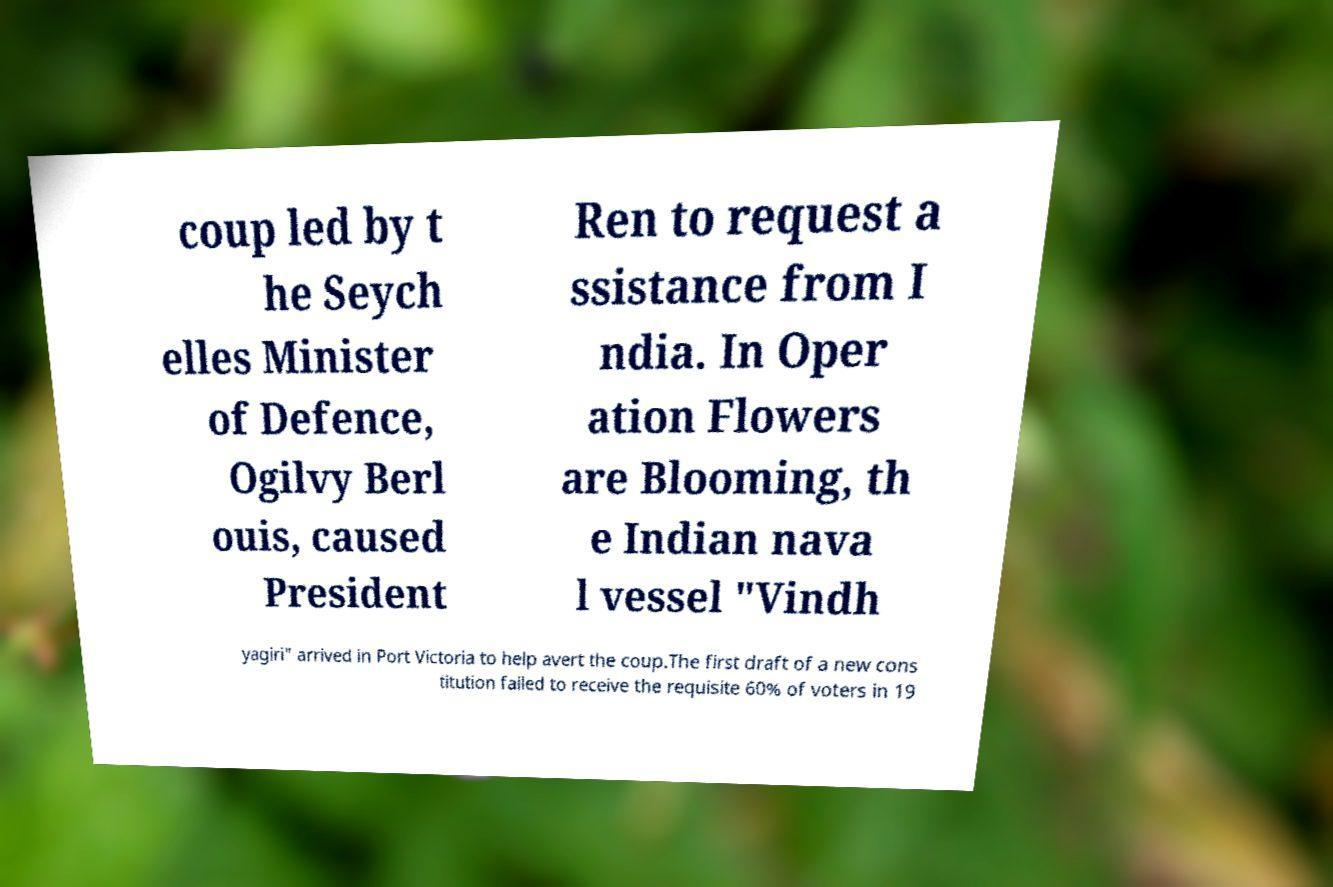Please identify and transcribe the text found in this image. coup led by t he Seych elles Minister of Defence, Ogilvy Berl ouis, caused President Ren to request a ssistance from I ndia. In Oper ation Flowers are Blooming, th e Indian nava l vessel "Vindh yagiri" arrived in Port Victoria to help avert the coup.The first draft of a new cons titution failed to receive the requisite 60% of voters in 19 